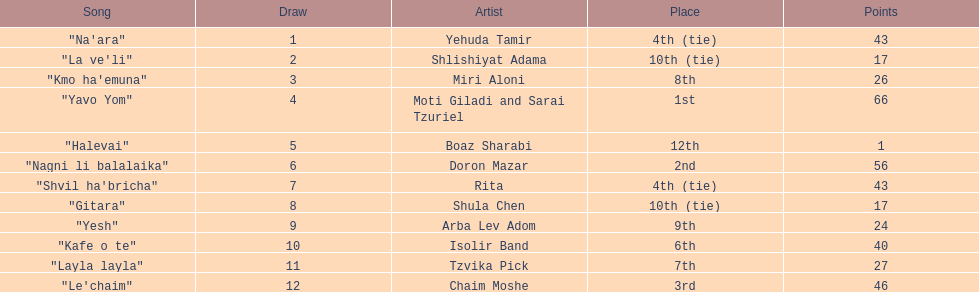Which artist had almost no points? Boaz Sharabi. 